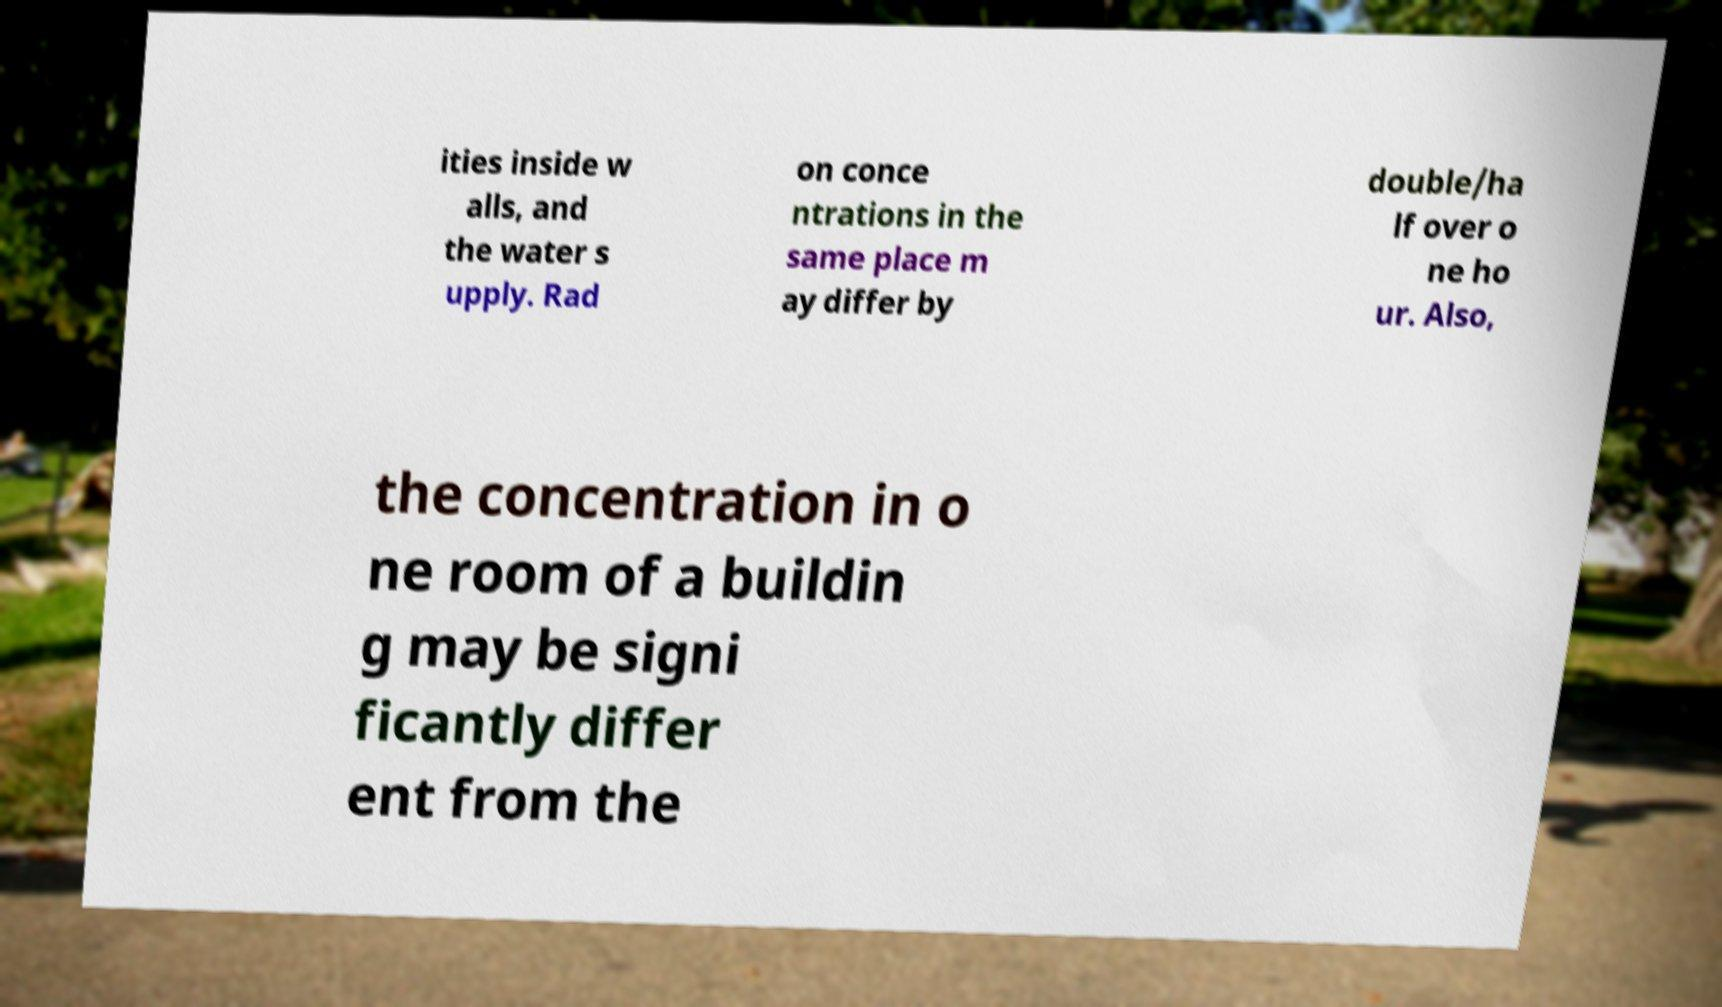For documentation purposes, I need the text within this image transcribed. Could you provide that? ities inside w alls, and the water s upply. Rad on conce ntrations in the same place m ay differ by double/ha lf over o ne ho ur. Also, the concentration in o ne room of a buildin g may be signi ficantly differ ent from the 